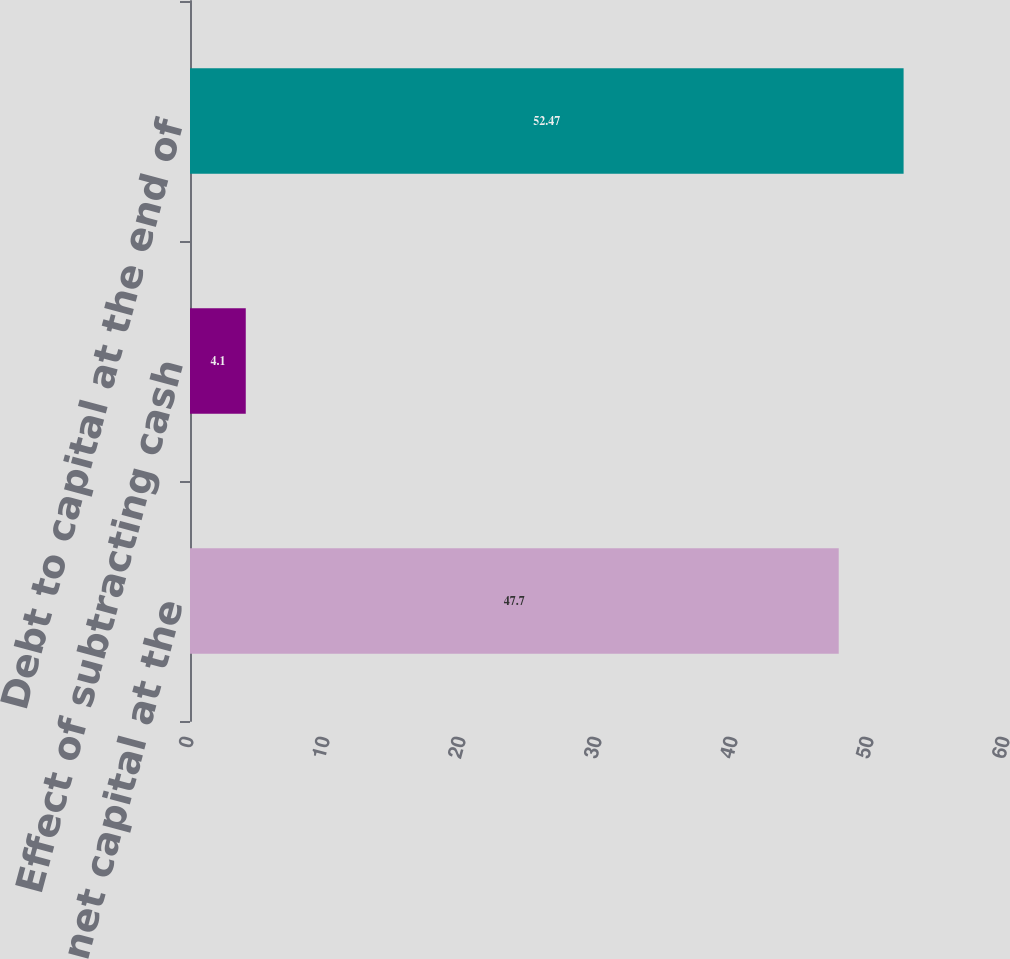<chart> <loc_0><loc_0><loc_500><loc_500><bar_chart><fcel>Net debt to net capital at the<fcel>Effect of subtracting cash<fcel>Debt to capital at the end of<nl><fcel>47.7<fcel>4.1<fcel>52.47<nl></chart> 